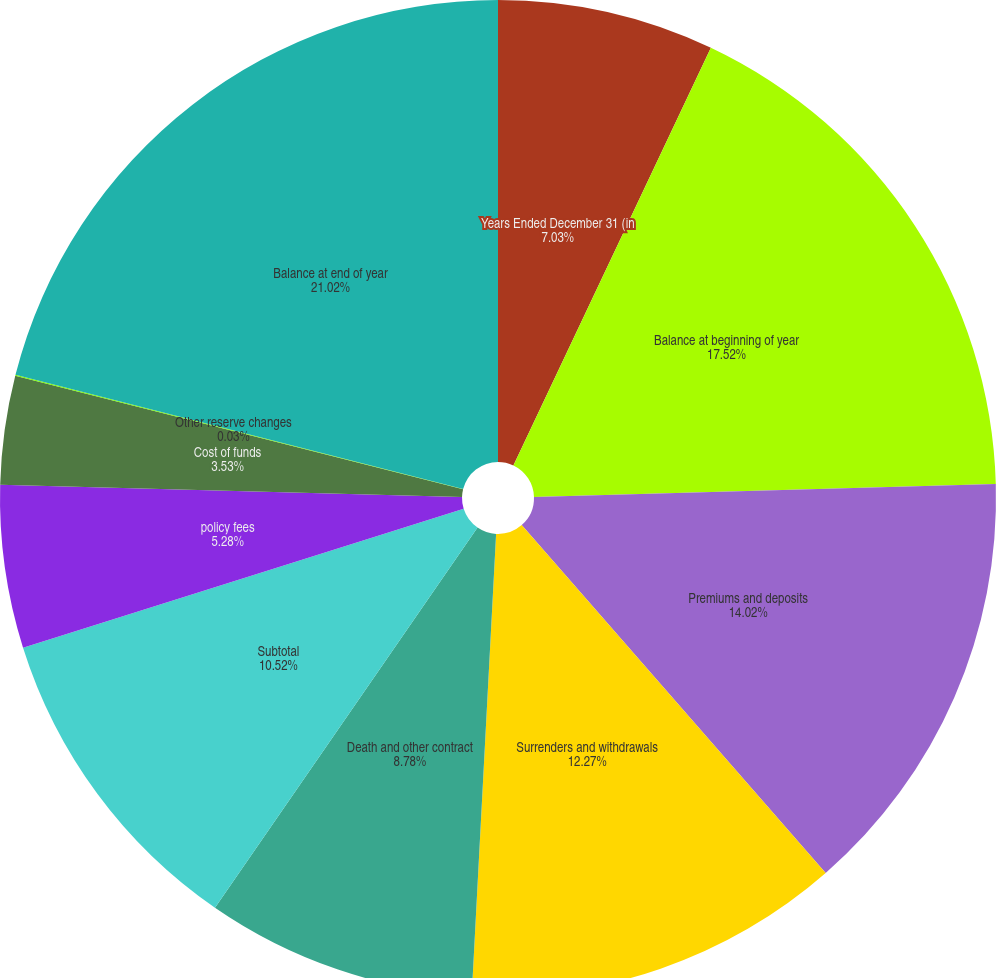Convert chart to OTSL. <chart><loc_0><loc_0><loc_500><loc_500><pie_chart><fcel>Years Ended December 31 (in<fcel>Balance at beginning of year<fcel>Premiums and deposits<fcel>Surrenders and withdrawals<fcel>Death and other contract<fcel>Subtotal<fcel>policy fees<fcel>Cost of funds<fcel>Other reserve changes<fcel>Balance at end of year<nl><fcel>7.03%<fcel>17.52%<fcel>14.02%<fcel>12.27%<fcel>8.78%<fcel>10.52%<fcel>5.28%<fcel>3.53%<fcel>0.03%<fcel>21.02%<nl></chart> 